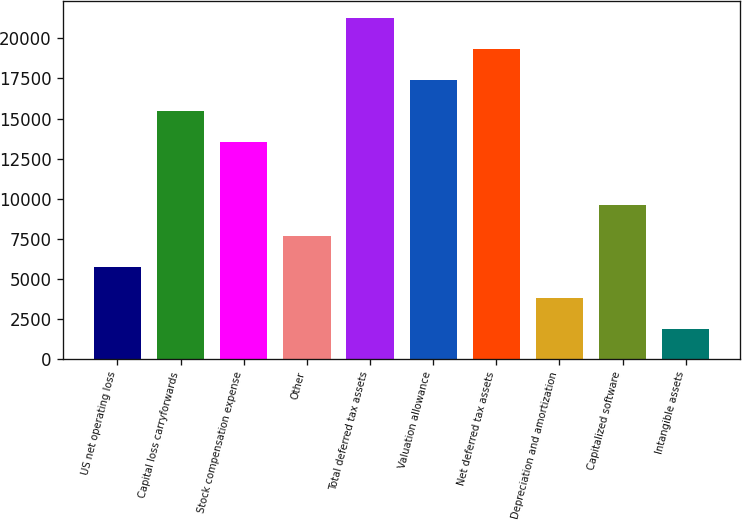Convert chart to OTSL. <chart><loc_0><loc_0><loc_500><loc_500><bar_chart><fcel>US net operating loss<fcel>Capital loss carryforwards<fcel>Stock compensation expense<fcel>Other<fcel>Total deferred tax assets<fcel>Valuation allowance<fcel>Net deferred tax assets<fcel>Depreciation and amortization<fcel>Capitalized software<fcel>Intangible assets<nl><fcel>5738.8<fcel>15450.8<fcel>13508.4<fcel>7681.2<fcel>21278<fcel>17393.2<fcel>19335.6<fcel>3796.4<fcel>9623.6<fcel>1854<nl></chart> 